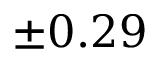<formula> <loc_0><loc_0><loc_500><loc_500>\pm 0 . 2 9</formula> 